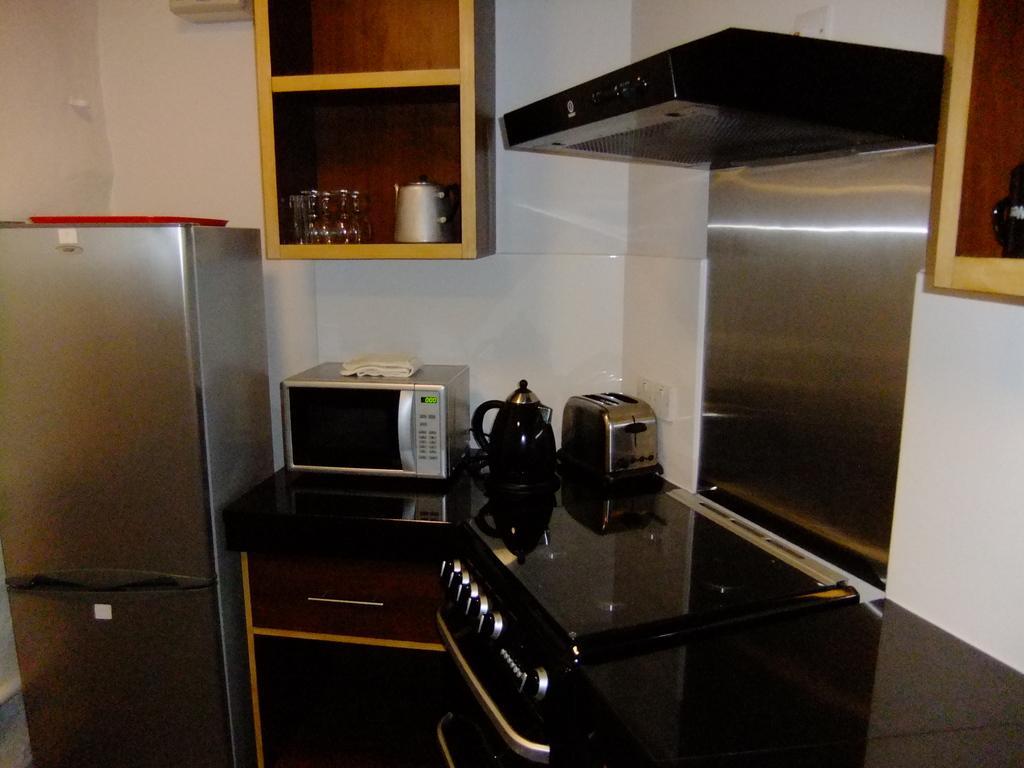Could you give a brief overview of what you see in this image? In this image we can see kettles, wall, refrigerator, glass objects, shelves and other objects. On the right side top of the image there is an object. 